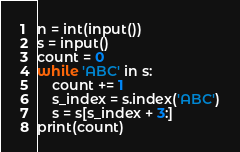<code> <loc_0><loc_0><loc_500><loc_500><_Python_>n = int(input())
s = input()
count = 0
while 'ABC' in s:
    count += 1
    s_index = s.index('ABC')
    s = s[s_index + 3:]
print(count)</code> 